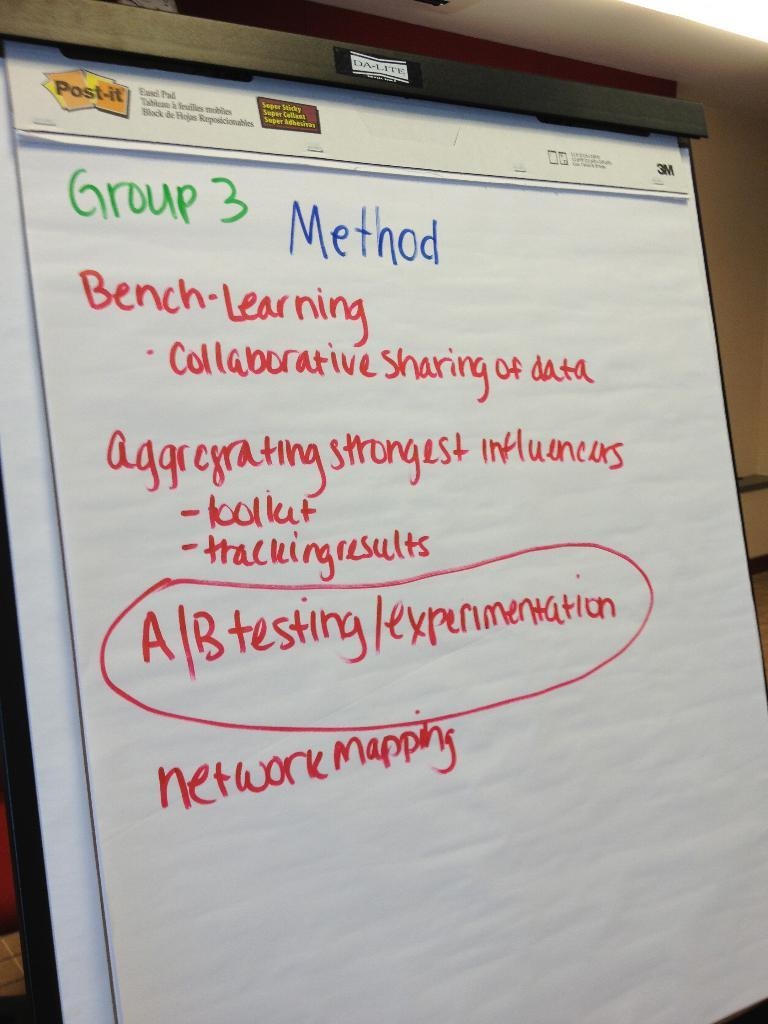What is located in the foreground of the image? There is a board in the foreground of the image. What can be seen on the board? There is text on the board. What is visible in the background of the image? There is a wall in the background of the image. How does the cow perform magic tricks in the image? There is no cow or magic tricks present in the image. 